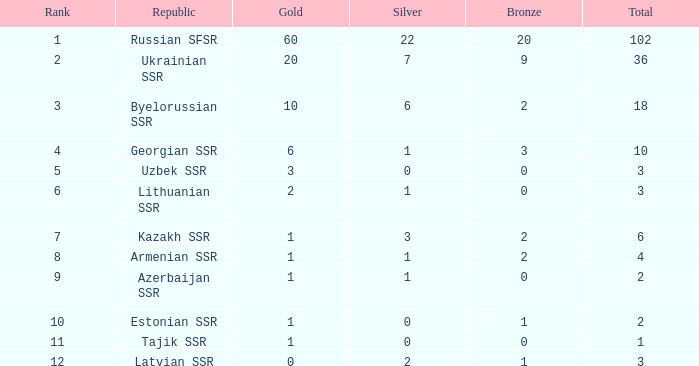What is the total number of bronze medals for teams with over 2 golds, a rank lower than 3, and fewer than 22 silvers? 9.0. 